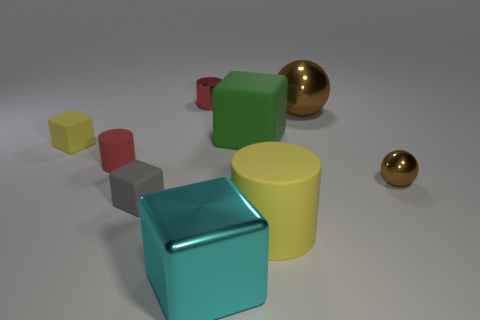What number of big things are made of the same material as the tiny brown sphere?
Your answer should be compact. 2. There is a matte cylinder on the left side of the green matte thing; does it have the same size as the yellow matte cylinder?
Your answer should be very brief. No. What is the color of the small cylinder that is the same material as the gray object?
Offer a very short reply. Red. Are there any other things that have the same size as the red matte object?
Provide a succinct answer. Yes. How many gray blocks are behind the tiny brown ball?
Offer a terse response. 0. Do the metal object that is in front of the yellow rubber cylinder and the tiny rubber cube that is behind the tiny brown sphere have the same color?
Keep it short and to the point. No. There is a large matte object that is the same shape as the tiny yellow object; what color is it?
Your answer should be compact. Green. Is there anything else that is the same shape as the small brown object?
Provide a succinct answer. Yes. Do the large metal thing that is in front of the large brown metal ball and the green thing that is to the left of the large brown sphere have the same shape?
Give a very brief answer. Yes. There is a yellow cube; is its size the same as the metallic thing that is in front of the small gray rubber thing?
Offer a terse response. No. 